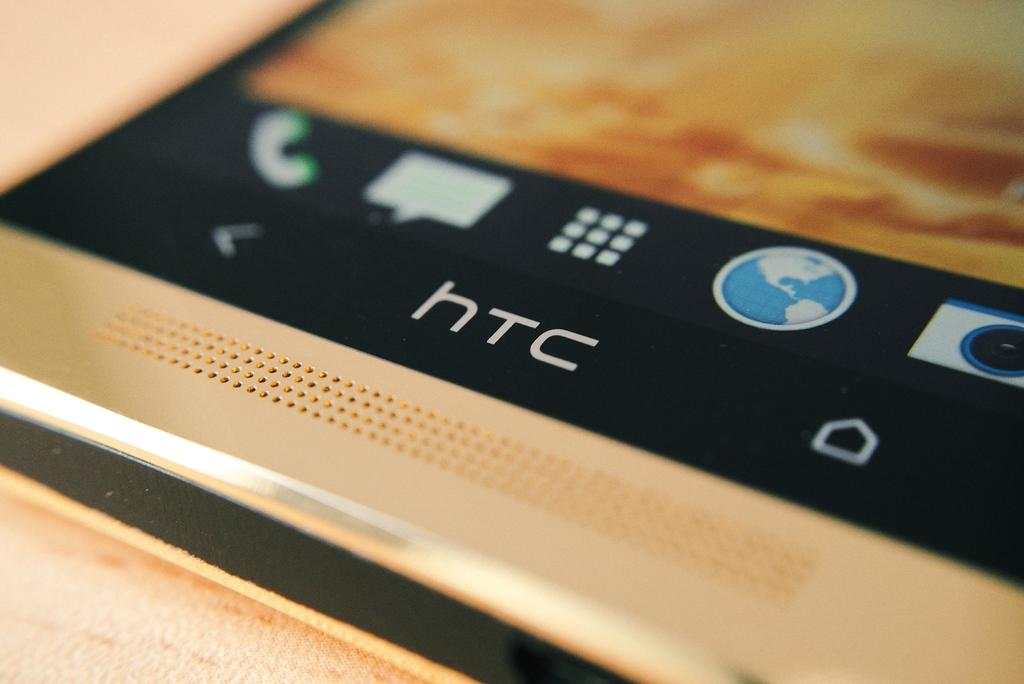Provide a one-sentence caption for the provided image. An electronic device, manufactured by HTC, is resting on a wooden surface. 